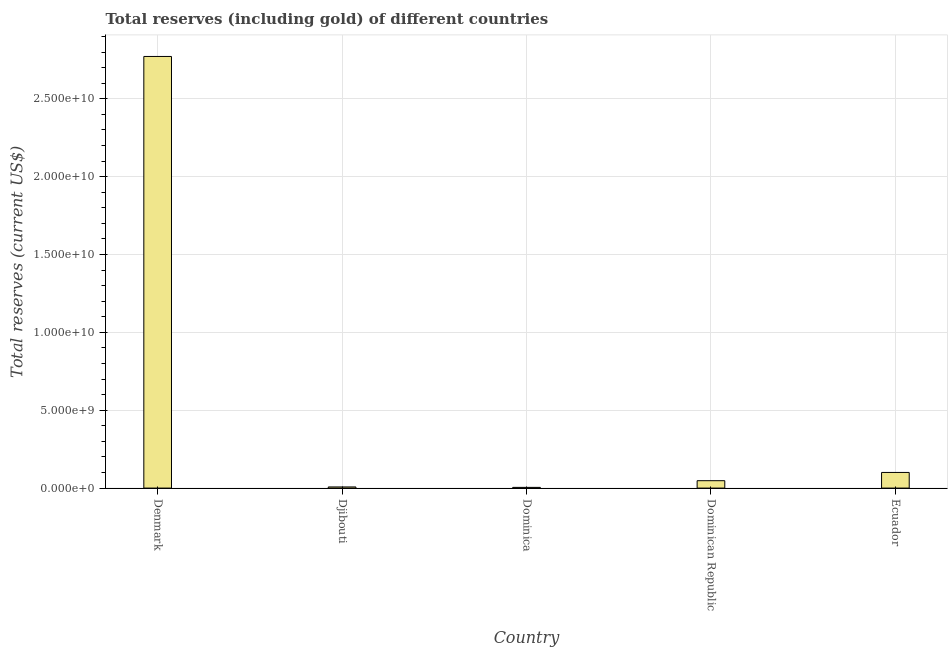Does the graph contain any zero values?
Offer a very short reply. No. What is the title of the graph?
Give a very brief answer. Total reserves (including gold) of different countries. What is the label or title of the Y-axis?
Offer a very short reply. Total reserves (current US$). What is the total reserves (including gold) in Denmark?
Your response must be concise. 2.77e+1. Across all countries, what is the maximum total reserves (including gold)?
Offer a very short reply. 2.77e+1. Across all countries, what is the minimum total reserves (including gold)?
Provide a succinct answer. 4.55e+07. In which country was the total reserves (including gold) minimum?
Offer a terse response. Dominica. What is the sum of the total reserves (including gold)?
Offer a very short reply. 2.93e+1. What is the difference between the total reserves (including gold) in Denmark and Dominican Republic?
Your answer should be compact. 2.72e+1. What is the average total reserves (including gold) per country?
Offer a terse response. 5.86e+09. What is the median total reserves (including gold)?
Provide a succinct answer. 4.75e+08. In how many countries, is the total reserves (including gold) greater than 11000000000 US$?
Provide a short and direct response. 1. What is the ratio of the total reserves (including gold) in Djibouti to that in Ecuador?
Provide a succinct answer. 0.07. What is the difference between the highest and the second highest total reserves (including gold)?
Ensure brevity in your answer.  2.67e+1. What is the difference between the highest and the lowest total reserves (including gold)?
Offer a terse response. 2.77e+1. How many bars are there?
Ensure brevity in your answer.  5. How many countries are there in the graph?
Ensure brevity in your answer.  5. What is the difference between two consecutive major ticks on the Y-axis?
Offer a very short reply. 5.00e+09. Are the values on the major ticks of Y-axis written in scientific E-notation?
Provide a short and direct response. Yes. What is the Total reserves (current US$) in Denmark?
Your response must be concise. 2.77e+1. What is the Total reserves (current US$) of Djibouti?
Provide a succinct answer. 7.37e+07. What is the Total reserves (current US$) of Dominica?
Give a very brief answer. 4.55e+07. What is the Total reserves (current US$) in Dominican Republic?
Keep it short and to the point. 4.75e+08. What is the Total reserves (current US$) in Ecuador?
Ensure brevity in your answer.  1.00e+09. What is the difference between the Total reserves (current US$) in Denmark and Djibouti?
Offer a very short reply. 2.76e+1. What is the difference between the Total reserves (current US$) in Denmark and Dominica?
Your response must be concise. 2.77e+1. What is the difference between the Total reserves (current US$) in Denmark and Dominican Republic?
Provide a short and direct response. 2.72e+1. What is the difference between the Total reserves (current US$) in Denmark and Ecuador?
Offer a very short reply. 2.67e+1. What is the difference between the Total reserves (current US$) in Djibouti and Dominica?
Provide a short and direct response. 2.82e+07. What is the difference between the Total reserves (current US$) in Djibouti and Dominican Republic?
Your response must be concise. -4.01e+08. What is the difference between the Total reserves (current US$) in Djibouti and Ecuador?
Your answer should be compact. -9.31e+08. What is the difference between the Total reserves (current US$) in Dominica and Dominican Republic?
Offer a very short reply. -4.29e+08. What is the difference between the Total reserves (current US$) in Dominica and Ecuador?
Offer a very short reply. -9.59e+08. What is the difference between the Total reserves (current US$) in Dominican Republic and Ecuador?
Offer a terse response. -5.30e+08. What is the ratio of the Total reserves (current US$) in Denmark to that in Djibouti?
Keep it short and to the point. 376.07. What is the ratio of the Total reserves (current US$) in Denmark to that in Dominica?
Keep it short and to the point. 609.25. What is the ratio of the Total reserves (current US$) in Denmark to that in Dominican Republic?
Provide a succinct answer. 58.4. What is the ratio of the Total reserves (current US$) in Denmark to that in Ecuador?
Ensure brevity in your answer.  27.6. What is the ratio of the Total reserves (current US$) in Djibouti to that in Dominica?
Give a very brief answer. 1.62. What is the ratio of the Total reserves (current US$) in Djibouti to that in Dominican Republic?
Your answer should be very brief. 0.15. What is the ratio of the Total reserves (current US$) in Djibouti to that in Ecuador?
Ensure brevity in your answer.  0.07. What is the ratio of the Total reserves (current US$) in Dominica to that in Dominican Republic?
Your answer should be compact. 0.1. What is the ratio of the Total reserves (current US$) in Dominica to that in Ecuador?
Your answer should be very brief. 0.04. What is the ratio of the Total reserves (current US$) in Dominican Republic to that in Ecuador?
Keep it short and to the point. 0.47. 